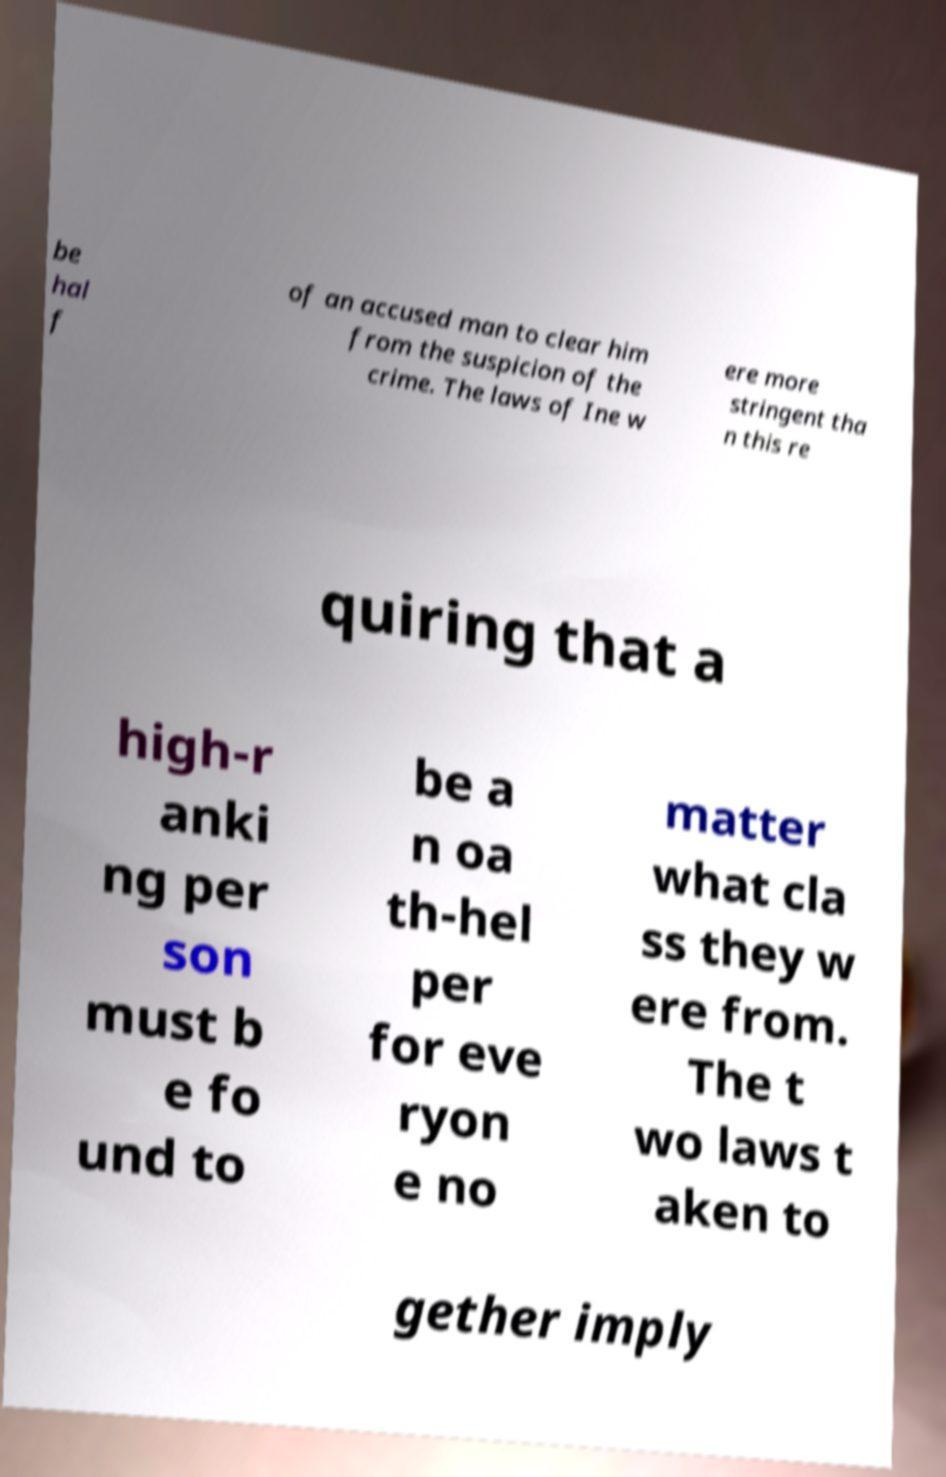Could you extract and type out the text from this image? be hal f of an accused man to clear him from the suspicion of the crime. The laws of Ine w ere more stringent tha n this re quiring that a high-r anki ng per son must b e fo und to be a n oa th-hel per for eve ryon e no matter what cla ss they w ere from. The t wo laws t aken to gether imply 